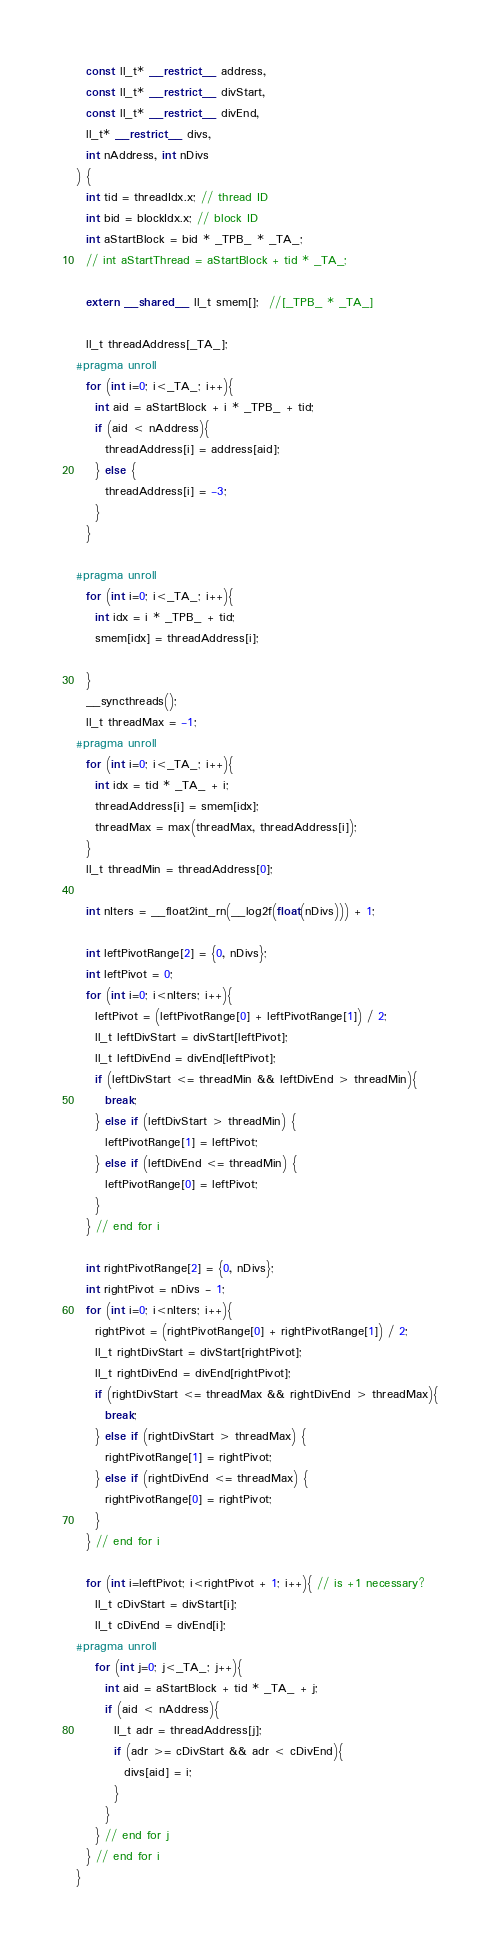Convert code to text. <code><loc_0><loc_0><loc_500><loc_500><_Cuda_>  const ll_t* __restrict__ address,
  const ll_t* __restrict__ divStart,
  const ll_t* __restrict__ divEnd,
  ll_t* __restrict__ divs,
  int nAddress, int nDivs
) {
  int tid = threadIdx.x; // thread ID
  int bid = blockIdx.x; // block ID
  int aStartBlock = bid * _TPB_ * _TA_;
  // int aStartThread = aStartBlock + tid * _TA_;

  extern __shared__ ll_t smem[];  //[_TPB_ * _TA_]

  ll_t threadAddress[_TA_];
#pragma unroll
  for (int i=0; i<_TA_; i++){
    int aid = aStartBlock + i * _TPB_ + tid;
    if (aid < nAddress){
      threadAddress[i] = address[aid];
    } else {
      threadAddress[i] = -3;
    }
  }

#pragma unroll
  for (int i=0; i<_TA_; i++){
    int idx = i * _TPB_ + tid;
    smem[idx] = threadAddress[i];

  }
  __syncthreads();
  ll_t threadMax = -1;
#pragma unroll
  for (int i=0; i<_TA_; i++){
    int idx = tid * _TA_ + i;
    threadAddress[i] = smem[idx];
    threadMax = max(threadMax, threadAddress[i]);
  }
  ll_t threadMin = threadAddress[0];

  int nIters = __float2int_rn(__log2f(float(nDivs))) + 1;
  
  int leftPivotRange[2] = {0, nDivs};
  int leftPivot = 0;
  for (int i=0; i<nIters; i++){
    leftPivot = (leftPivotRange[0] + leftPivotRange[1]) / 2;
    ll_t leftDivStart = divStart[leftPivot];
    ll_t leftDivEnd = divEnd[leftPivot];
    if (leftDivStart <= threadMin && leftDivEnd > threadMin){
      break;
    } else if (leftDivStart > threadMin) {
      leftPivotRange[1] = leftPivot;
    } else if (leftDivEnd <= threadMin) {
      leftPivotRange[0] = leftPivot;
    }
  } // end for i

  int rightPivotRange[2] = {0, nDivs};
  int rightPivot = nDivs - 1;
  for (int i=0; i<nIters; i++){
    rightPivot = (rightPivotRange[0] + rightPivotRange[1]) / 2;
    ll_t rightDivStart = divStart[rightPivot];
    ll_t rightDivEnd = divEnd[rightPivot];
    if (rightDivStart <= threadMax && rightDivEnd > threadMax){
      break;
    } else if (rightDivStart > threadMax) {
      rightPivotRange[1] = rightPivot;
    } else if (rightDivEnd <= threadMax) {
      rightPivotRange[0] = rightPivot;
    }
  } // end for i

  for (int i=leftPivot; i<rightPivot + 1; i++){ // is +1 necessary?
    ll_t cDivStart = divStart[i];
    ll_t cDivEnd = divEnd[i];
#pragma unroll
    for (int j=0; j<_TA_; j++){
      int aid = aStartBlock + tid * _TA_ + j;
      if (aid < nAddress){
        ll_t adr = threadAddress[j];
        if (adr >= cDivStart && adr < cDivEnd){
          divs[aid] = i;
        }
      }
    } // end for j
  } // end for i
}</code> 